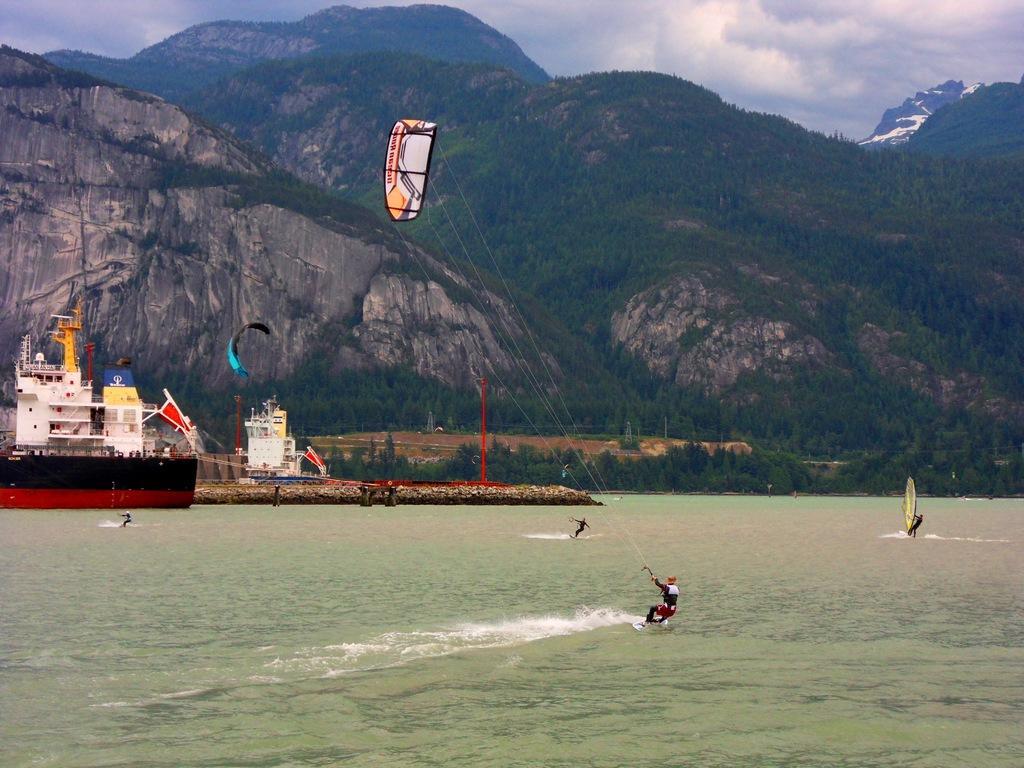Could you give a brief overview of what you see in this image? In this picture I can see a ship and few people kite surfing on the water and I can see a human on the boat. I can see few trees, hills and a blue cloudy sky. 